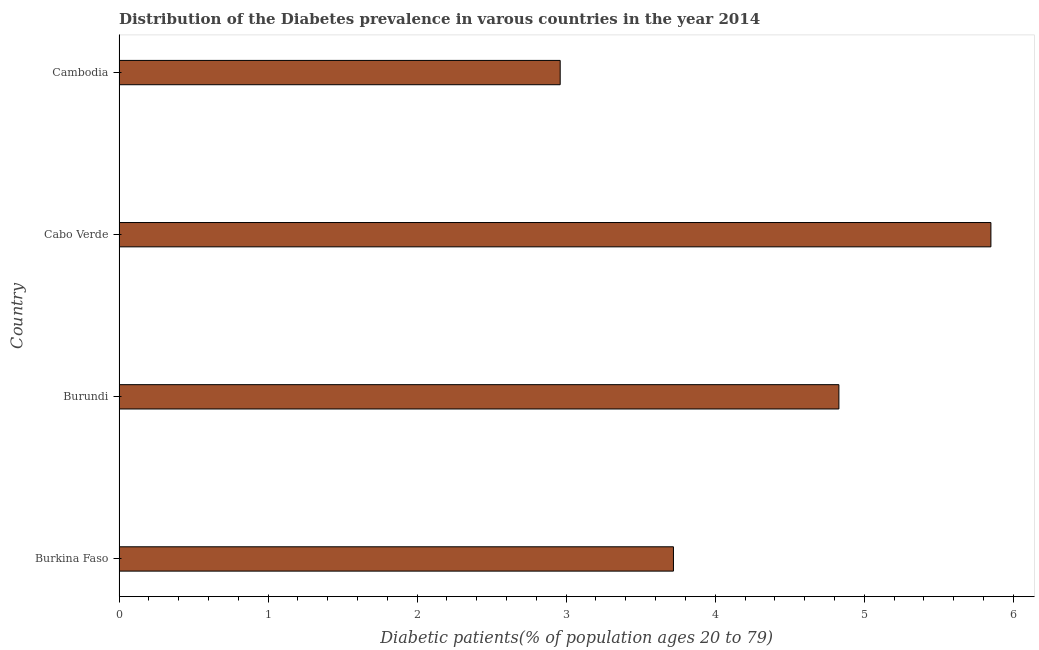Does the graph contain any zero values?
Offer a terse response. No. Does the graph contain grids?
Offer a very short reply. No. What is the title of the graph?
Offer a terse response. Distribution of the Diabetes prevalence in varous countries in the year 2014. What is the label or title of the X-axis?
Provide a succinct answer. Diabetic patients(% of population ages 20 to 79). What is the number of diabetic patients in Burkina Faso?
Ensure brevity in your answer.  3.72. Across all countries, what is the maximum number of diabetic patients?
Give a very brief answer. 5.85. Across all countries, what is the minimum number of diabetic patients?
Offer a terse response. 2.96. In which country was the number of diabetic patients maximum?
Offer a very short reply. Cabo Verde. In which country was the number of diabetic patients minimum?
Offer a very short reply. Cambodia. What is the sum of the number of diabetic patients?
Offer a terse response. 17.36. What is the difference between the number of diabetic patients in Burundi and Cabo Verde?
Your answer should be very brief. -1.02. What is the average number of diabetic patients per country?
Your answer should be very brief. 4.34. What is the median number of diabetic patients?
Provide a succinct answer. 4.28. In how many countries, is the number of diabetic patients greater than 3 %?
Offer a terse response. 3. What is the ratio of the number of diabetic patients in Burkina Faso to that in Cambodia?
Give a very brief answer. 1.26. What is the difference between the highest and the second highest number of diabetic patients?
Provide a succinct answer. 1.02. Is the sum of the number of diabetic patients in Burkina Faso and Cabo Verde greater than the maximum number of diabetic patients across all countries?
Provide a succinct answer. Yes. What is the difference between the highest and the lowest number of diabetic patients?
Keep it short and to the point. 2.89. Are all the bars in the graph horizontal?
Ensure brevity in your answer.  Yes. How many countries are there in the graph?
Keep it short and to the point. 4. What is the Diabetic patients(% of population ages 20 to 79) in Burkina Faso?
Your response must be concise. 3.72. What is the Diabetic patients(% of population ages 20 to 79) of Burundi?
Your answer should be compact. 4.83. What is the Diabetic patients(% of population ages 20 to 79) of Cabo Verde?
Offer a very short reply. 5.85. What is the Diabetic patients(% of population ages 20 to 79) in Cambodia?
Keep it short and to the point. 2.96. What is the difference between the Diabetic patients(% of population ages 20 to 79) in Burkina Faso and Burundi?
Keep it short and to the point. -1.11. What is the difference between the Diabetic patients(% of population ages 20 to 79) in Burkina Faso and Cabo Verde?
Offer a terse response. -2.13. What is the difference between the Diabetic patients(% of population ages 20 to 79) in Burkina Faso and Cambodia?
Your answer should be very brief. 0.76. What is the difference between the Diabetic patients(% of population ages 20 to 79) in Burundi and Cabo Verde?
Offer a very short reply. -1.02. What is the difference between the Diabetic patients(% of population ages 20 to 79) in Burundi and Cambodia?
Offer a very short reply. 1.87. What is the difference between the Diabetic patients(% of population ages 20 to 79) in Cabo Verde and Cambodia?
Provide a succinct answer. 2.89. What is the ratio of the Diabetic patients(% of population ages 20 to 79) in Burkina Faso to that in Burundi?
Your answer should be compact. 0.77. What is the ratio of the Diabetic patients(% of population ages 20 to 79) in Burkina Faso to that in Cabo Verde?
Ensure brevity in your answer.  0.64. What is the ratio of the Diabetic patients(% of population ages 20 to 79) in Burkina Faso to that in Cambodia?
Provide a short and direct response. 1.26. What is the ratio of the Diabetic patients(% of population ages 20 to 79) in Burundi to that in Cabo Verde?
Provide a short and direct response. 0.83. What is the ratio of the Diabetic patients(% of population ages 20 to 79) in Burundi to that in Cambodia?
Offer a terse response. 1.63. What is the ratio of the Diabetic patients(% of population ages 20 to 79) in Cabo Verde to that in Cambodia?
Offer a terse response. 1.98. 